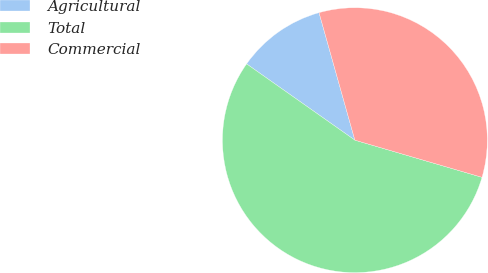<chart> <loc_0><loc_0><loc_500><loc_500><pie_chart><fcel>Agricultural<fcel>Total<fcel>Commercial<nl><fcel>10.87%<fcel>55.24%<fcel>33.89%<nl></chart> 